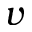<formula> <loc_0><loc_0><loc_500><loc_500>v</formula> 